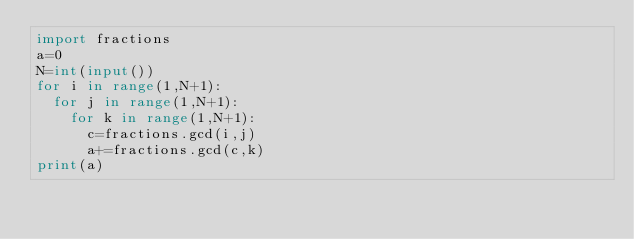Convert code to text. <code><loc_0><loc_0><loc_500><loc_500><_Python_>import fractions
a=0
N=int(input())
for i in range(1,N+1):
  for j in range(1,N+1):
    for k in range(1,N+1):
      c=fractions.gcd(i,j)
      a+=fractions.gcd(c,k)
print(a)</code> 